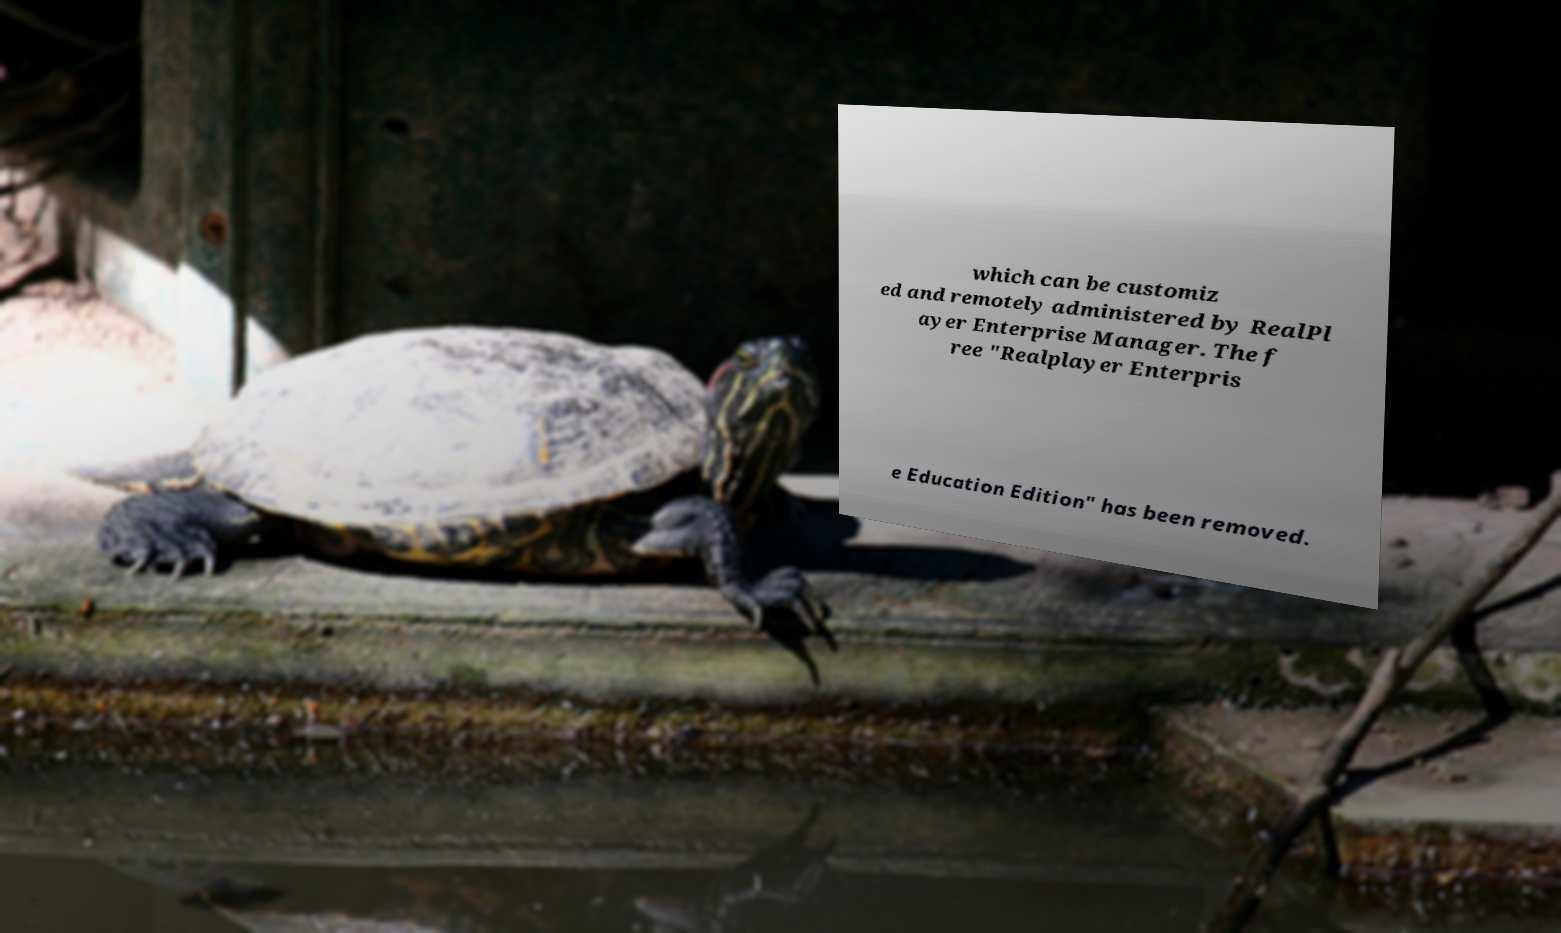For documentation purposes, I need the text within this image transcribed. Could you provide that? which can be customiz ed and remotely administered by RealPl ayer Enterprise Manager. The f ree "Realplayer Enterpris e Education Edition" has been removed. 